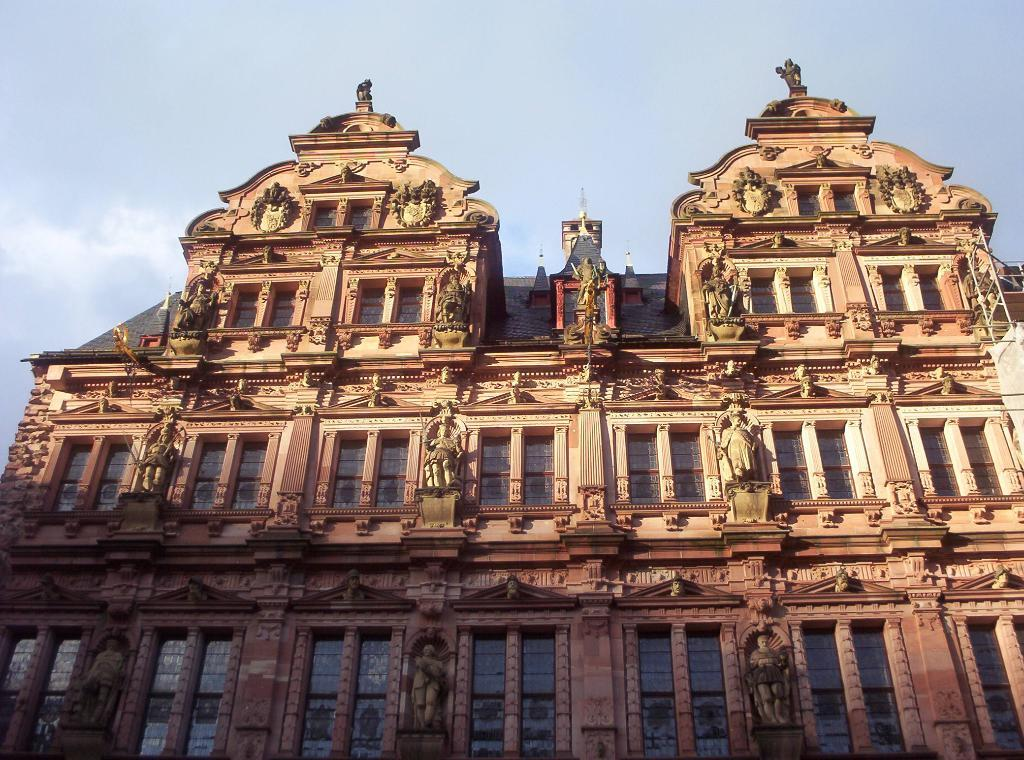What is the main subject of the image? There is a building in the image. What type of pest can be seen crawling on the building in the image? There is no pest visible on the building in the image. What causes the spark that illuminates the building in the image? There is no spark or illumination mentioned in the image, as only the building is described. 